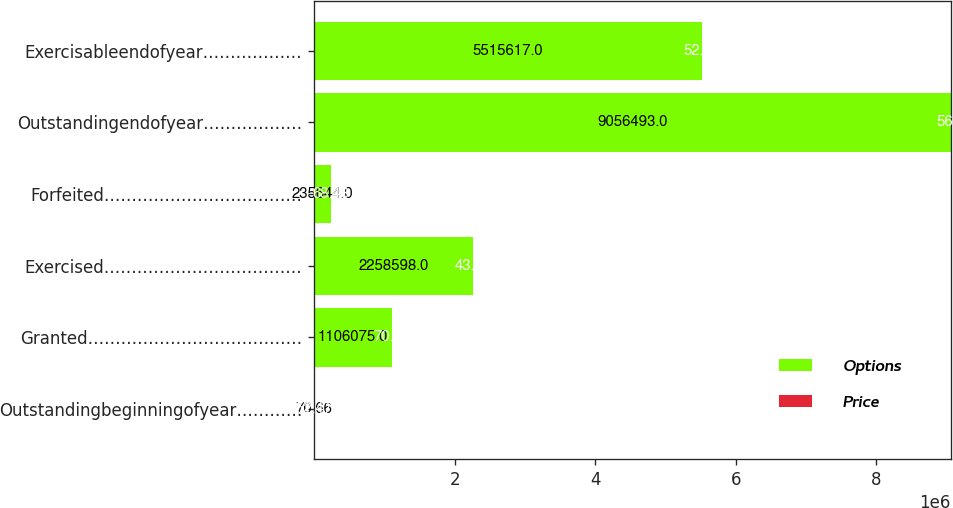<chart> <loc_0><loc_0><loc_500><loc_500><stacked_bar_chart><ecel><fcel>Outstandingbeginningofyear…………<fcel>Granted…………………………………<fcel>Exercised………………………………<fcel>Forfeited………………………………<fcel>Outstandingendofyear………………<fcel>Exercisableendofyear………………<nl><fcel>Options<fcel>70.66<fcel>1.10608e+06<fcel>2.2586e+06<fcel>235644<fcel>9.05649e+06<fcel>5.51562e+06<nl><fcel>Price<fcel>52.47<fcel>70.66<fcel>43.07<fcel>68.48<fcel>56.9<fcel>52.97<nl></chart> 